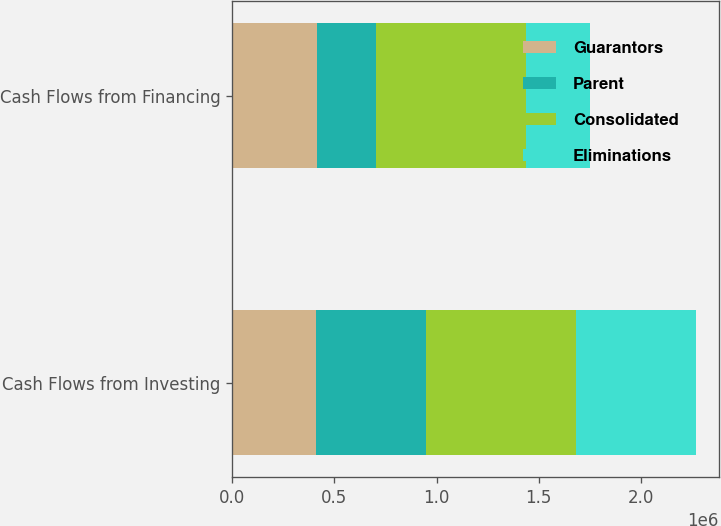<chart> <loc_0><loc_0><loc_500><loc_500><stacked_bar_chart><ecel><fcel>Cash Flows from Investing<fcel>Cash Flows from Financing<nl><fcel>Guarantors<fcel>408997<fcel>412820<nl><fcel>Parent<fcel>537619<fcel>288212<nl><fcel>Consolidated<fcel>735682<fcel>735682<nl><fcel>Eliminations<fcel>586634<fcel>315054<nl></chart> 